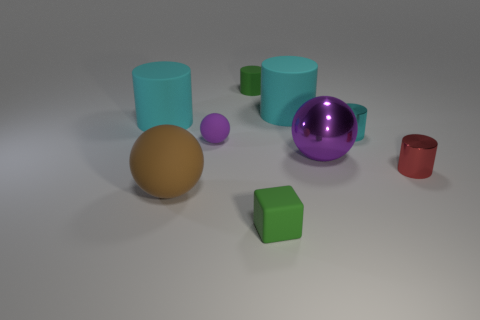Can you describe the textures visible in the image? Certainly! In the image, all the objects have a smooth surface finish, but there's a variety of visual textures due to the different material properties. The cyan and purple objects have a glossy, reflective texture. The green cube and red cup have a slightly less reflective, matte finish. The orange and tan spheres feature a diffuse, matte texture with no reflection. 